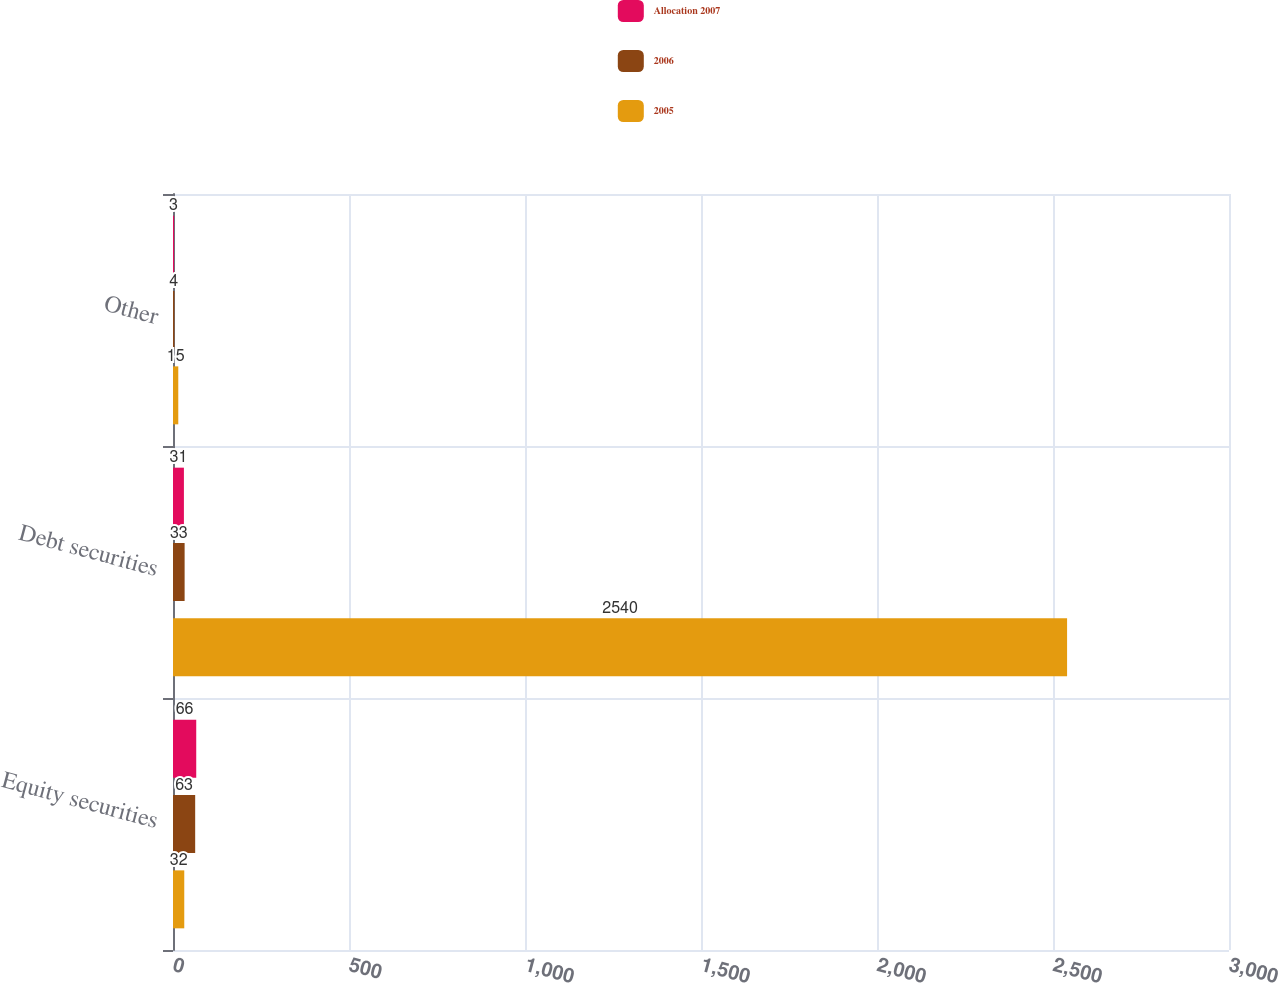Convert chart to OTSL. <chart><loc_0><loc_0><loc_500><loc_500><stacked_bar_chart><ecel><fcel>Equity securities<fcel>Debt securities<fcel>Other<nl><fcel>Allocation 2007<fcel>66<fcel>31<fcel>3<nl><fcel>2006<fcel>63<fcel>33<fcel>4<nl><fcel>2005<fcel>32<fcel>2540<fcel>15<nl></chart> 